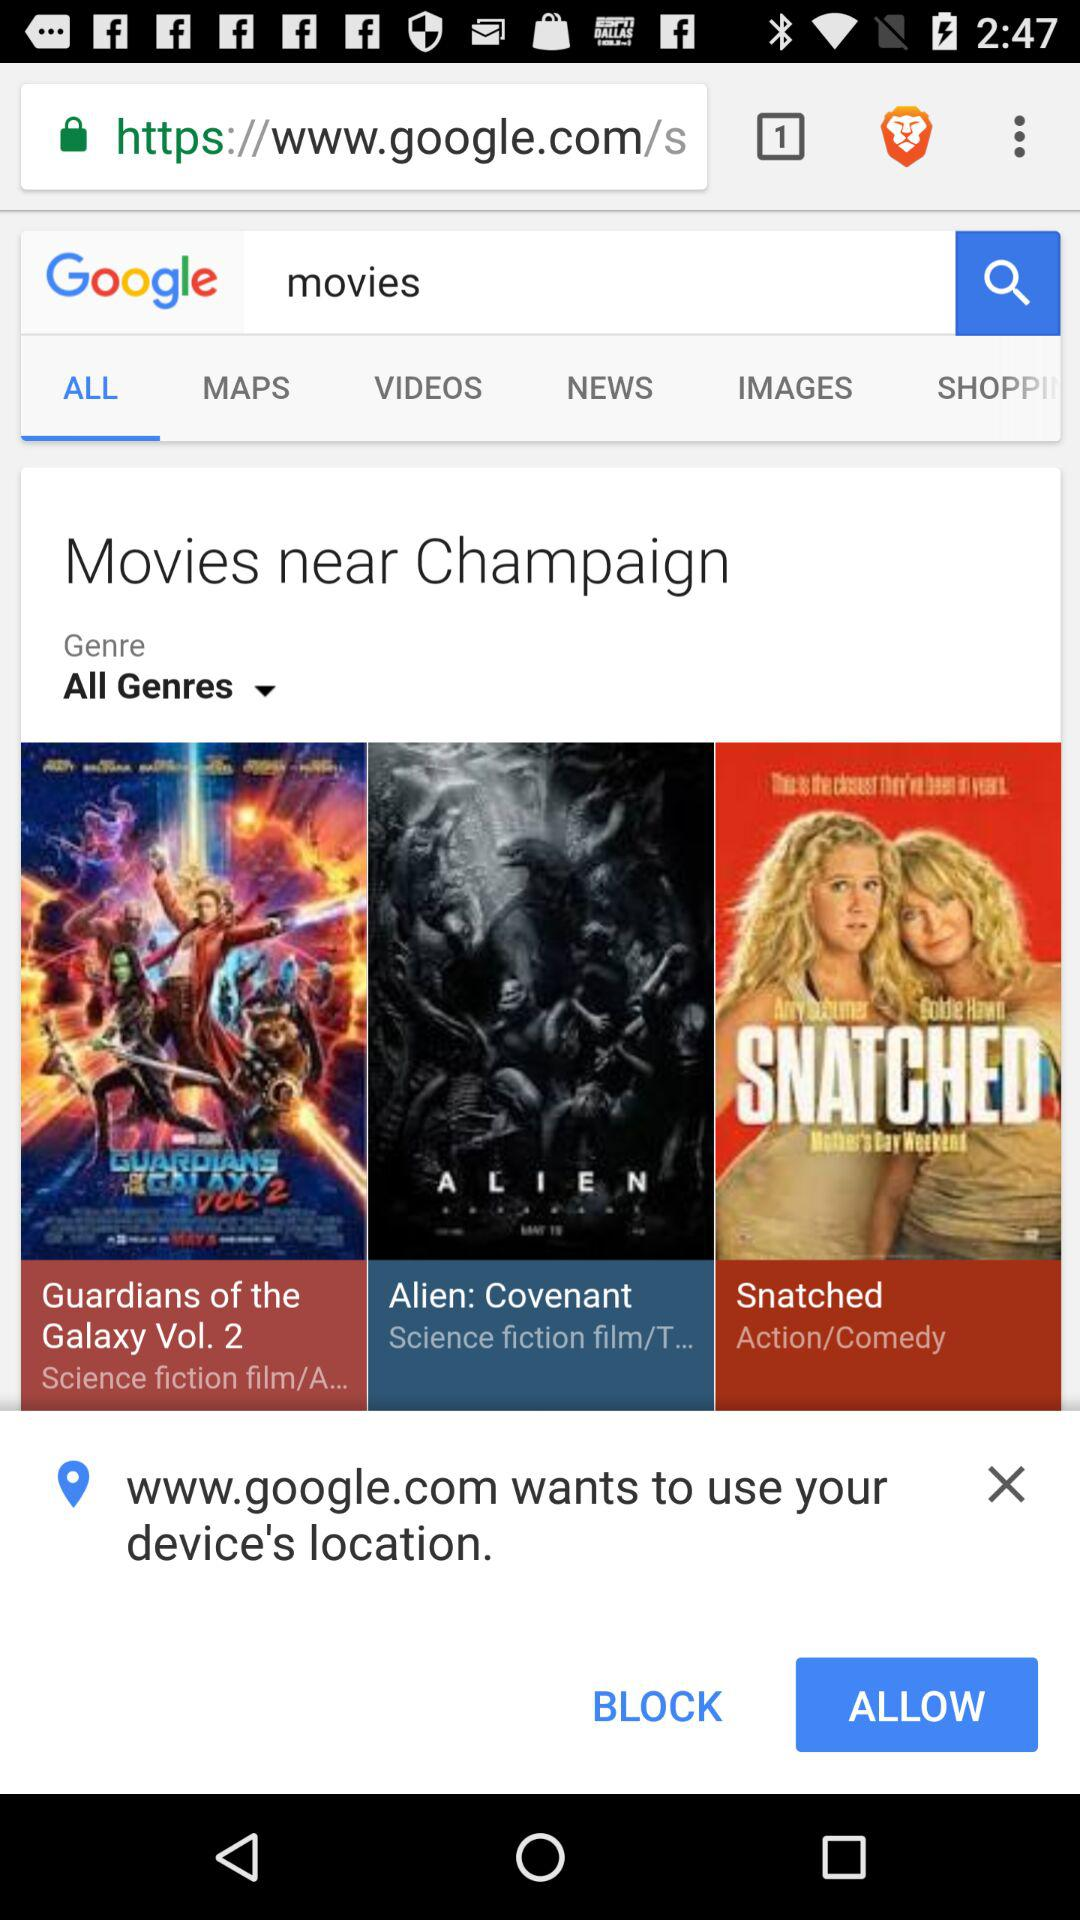Which tab is selected? The selected tab is "ALL". 